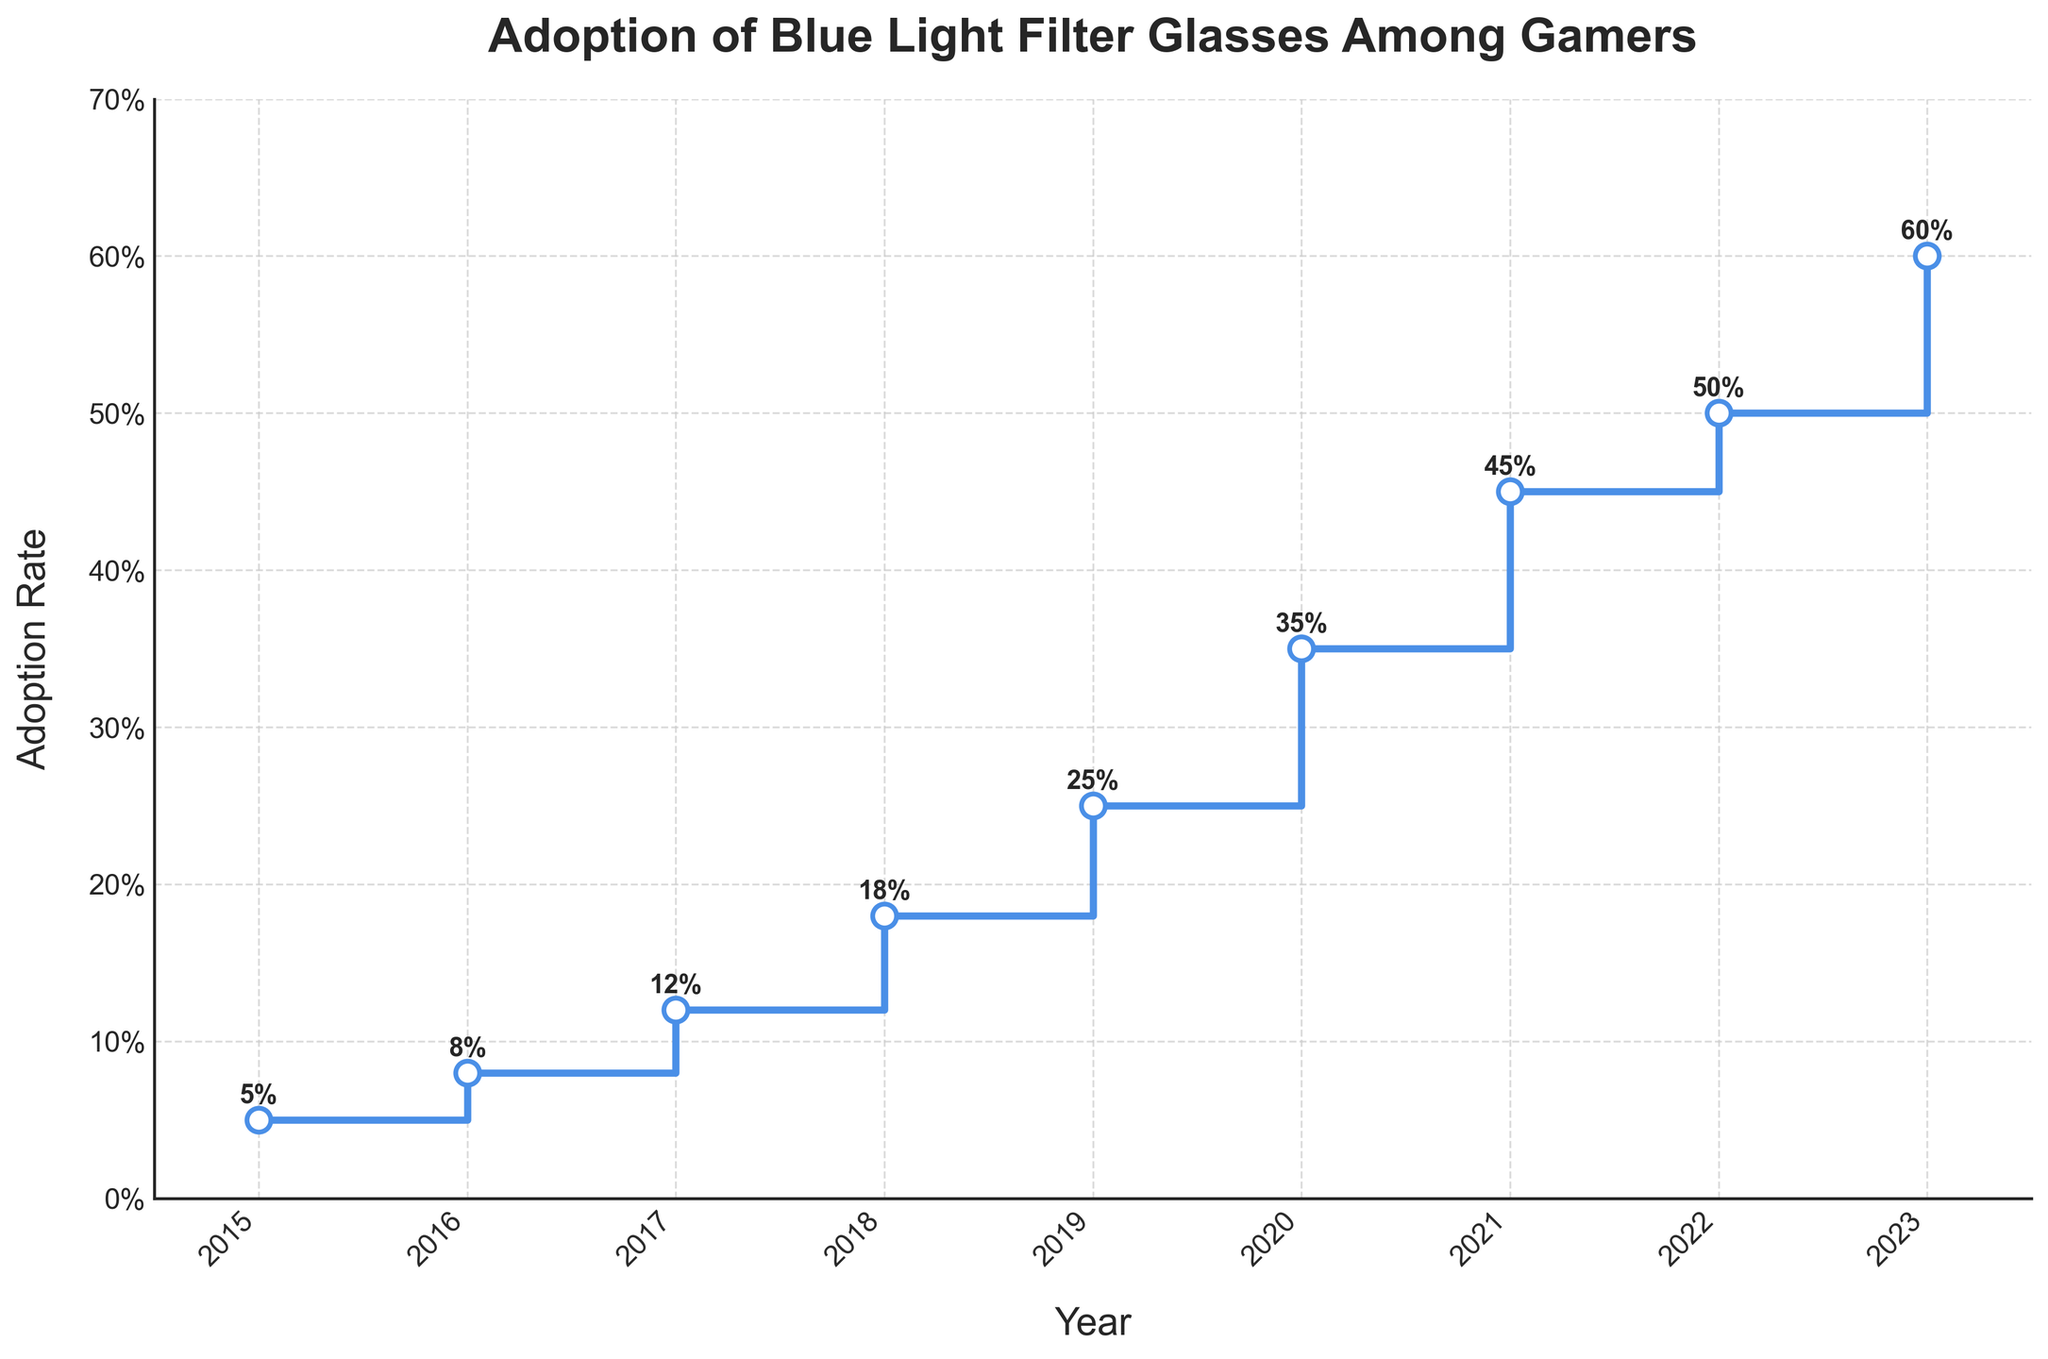What is the title of the plot? The title of the plot is the text at the top of the chart, meant to describe what the plot is about. The title is "Adoption of Blue Light Filter Glasses Among Gamers".
Answer: Adoption of Blue Light Filter Glasses Among Gamers What does the y-axis represent in the chart? The y-axis usually represents the variable being measured. In this case, it's labeled as "Adoption Rate", which indicates the percentage at which gamers are adopting blue light filter glasses.
Answer: Adoption Rate How many years of data are shown in the plot? To find the number of years, count the distinct points along the x-axis. The plot shows data for each year from 2015 to 2023.
Answer: 9 years What was the adoption rate in 2018? Locate the 2018 point on the x-axis and trace up to where it intersects with the stair step. The adoption rate is annotated on the plot as 18%.
Answer: 18% Between which two consecutive years did the adoption rate increase the most? To determine this, calculate the differences in adoption rates between consecutive years. The differences are: 2016-2015 (3%), 2017-2016 (4%), 2018-2017 (6%), 2019-2018 (7%), 2020-2019 (10%), 2021-2020 (10%), 2022-2021 (5%), and 2023-2022 (10%). The maximum increase of 10% occurred in 2020-2019, 2021-2020, and 2023-2022.
Answer: 2022-2023, 2020-2021, 2019-2020 By how much did the adoption rate increase from 2015 to 2023? Subtract the adoption rate in 2015 from the rate in 2023. The rate in 2015 is 5%, and in 2023 it is 60%. (60% - 5% = 55%)
Answer: 55% What is the average adoption rate across all years shown? Sum all the adoption rates and divide by the number of years. The rates are 5, 8, 12, 18, 25, 35, 45, 50, 60. Sum = 258. Number of years = 9. Average = 258 / 9 ≈ 28.67%
Answer: 28.67% Which year had the highest adoption rate? Identify the highest point on the y-axis and its corresponding year. In 2023, the adoption rate was 60%, which is the highest.
Answer: 2023 Did the adoption rate ever decrease year-over-year in the given data? Check each step in the stair plot to see if the rate goes down at any point. The plot shows a constant increase every year from 2015 to 2023.
Answer: No 